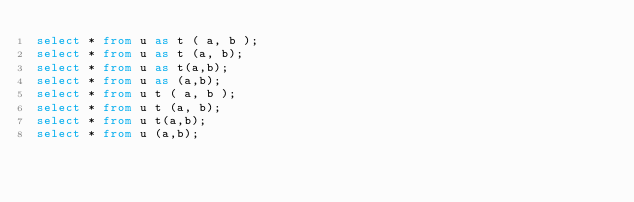<code> <loc_0><loc_0><loc_500><loc_500><_SQL_>select * from u as t ( a, b );
select * from u as t (a, b);
select * from u as t(a,b);
select * from u as (a,b);
select * from u t ( a, b );
select * from u t (a, b);
select * from u t(a,b);
select * from u (a,b);
</code> 